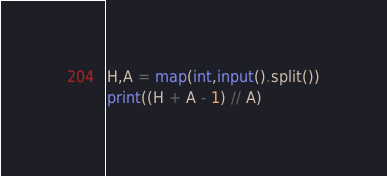<code> <loc_0><loc_0><loc_500><loc_500><_Python_>H,A = map(int,input().split())
print((H + A - 1) // A)</code> 